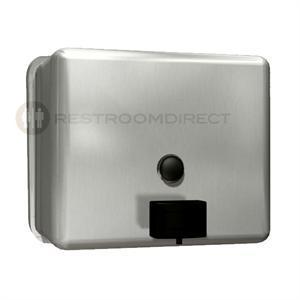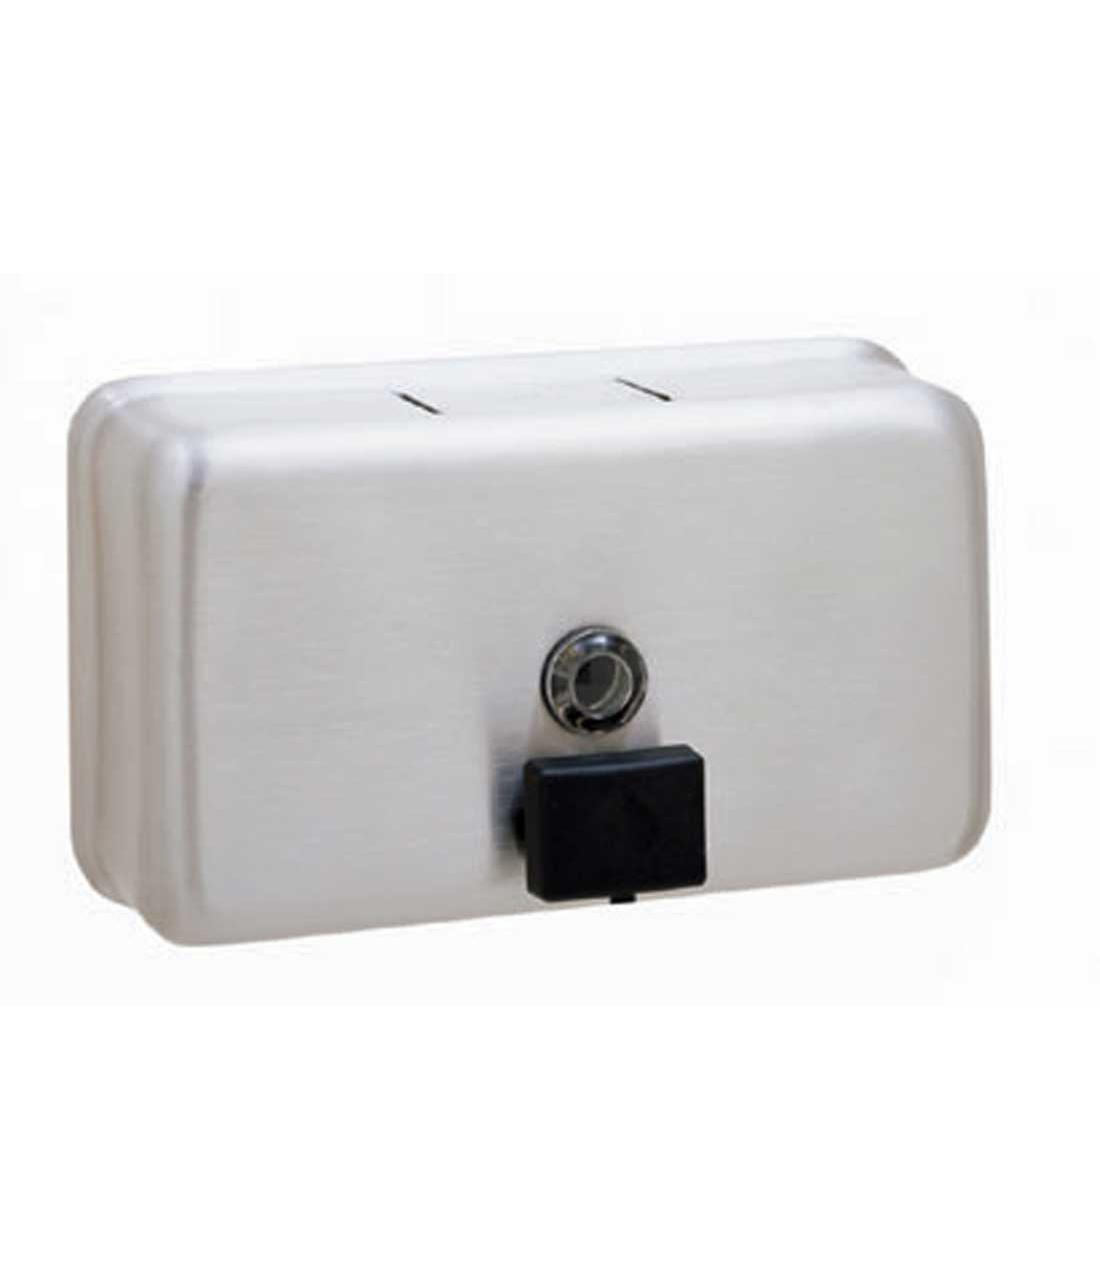The first image is the image on the left, the second image is the image on the right. For the images displayed, is the sentence "The object in the image on the left is turned toward the right." factually correct? Answer yes or no. Yes. 